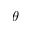Convert formula to latex. <formula><loc_0><loc_0><loc_500><loc_500>\theta</formula> 